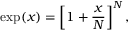<formula> <loc_0><loc_0><loc_500><loc_500>\exp ( x ) = \left [ 1 + { \frac { x } { N } } \right ] ^ { N } ,</formula> 